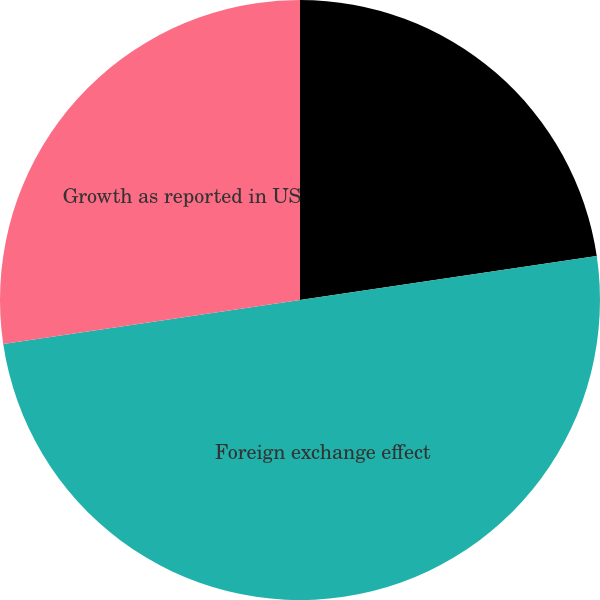<chart> <loc_0><loc_0><loc_500><loc_500><pie_chart><fcel>Growth in original currency<fcel>Foreign exchange effect<fcel>Growth as reported in US<nl><fcel>22.66%<fcel>50.0%<fcel>27.34%<nl></chart> 